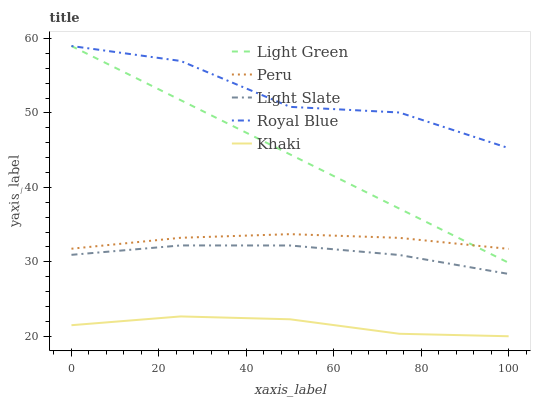Does Royal Blue have the minimum area under the curve?
Answer yes or no. No. Does Khaki have the maximum area under the curve?
Answer yes or no. No. Is Khaki the smoothest?
Answer yes or no. No. Is Khaki the roughest?
Answer yes or no. No. Does Royal Blue have the lowest value?
Answer yes or no. No. Does Khaki have the highest value?
Answer yes or no. No. Is Khaki less than Light Slate?
Answer yes or no. Yes. Is Royal Blue greater than Khaki?
Answer yes or no. Yes. Does Khaki intersect Light Slate?
Answer yes or no. No. 